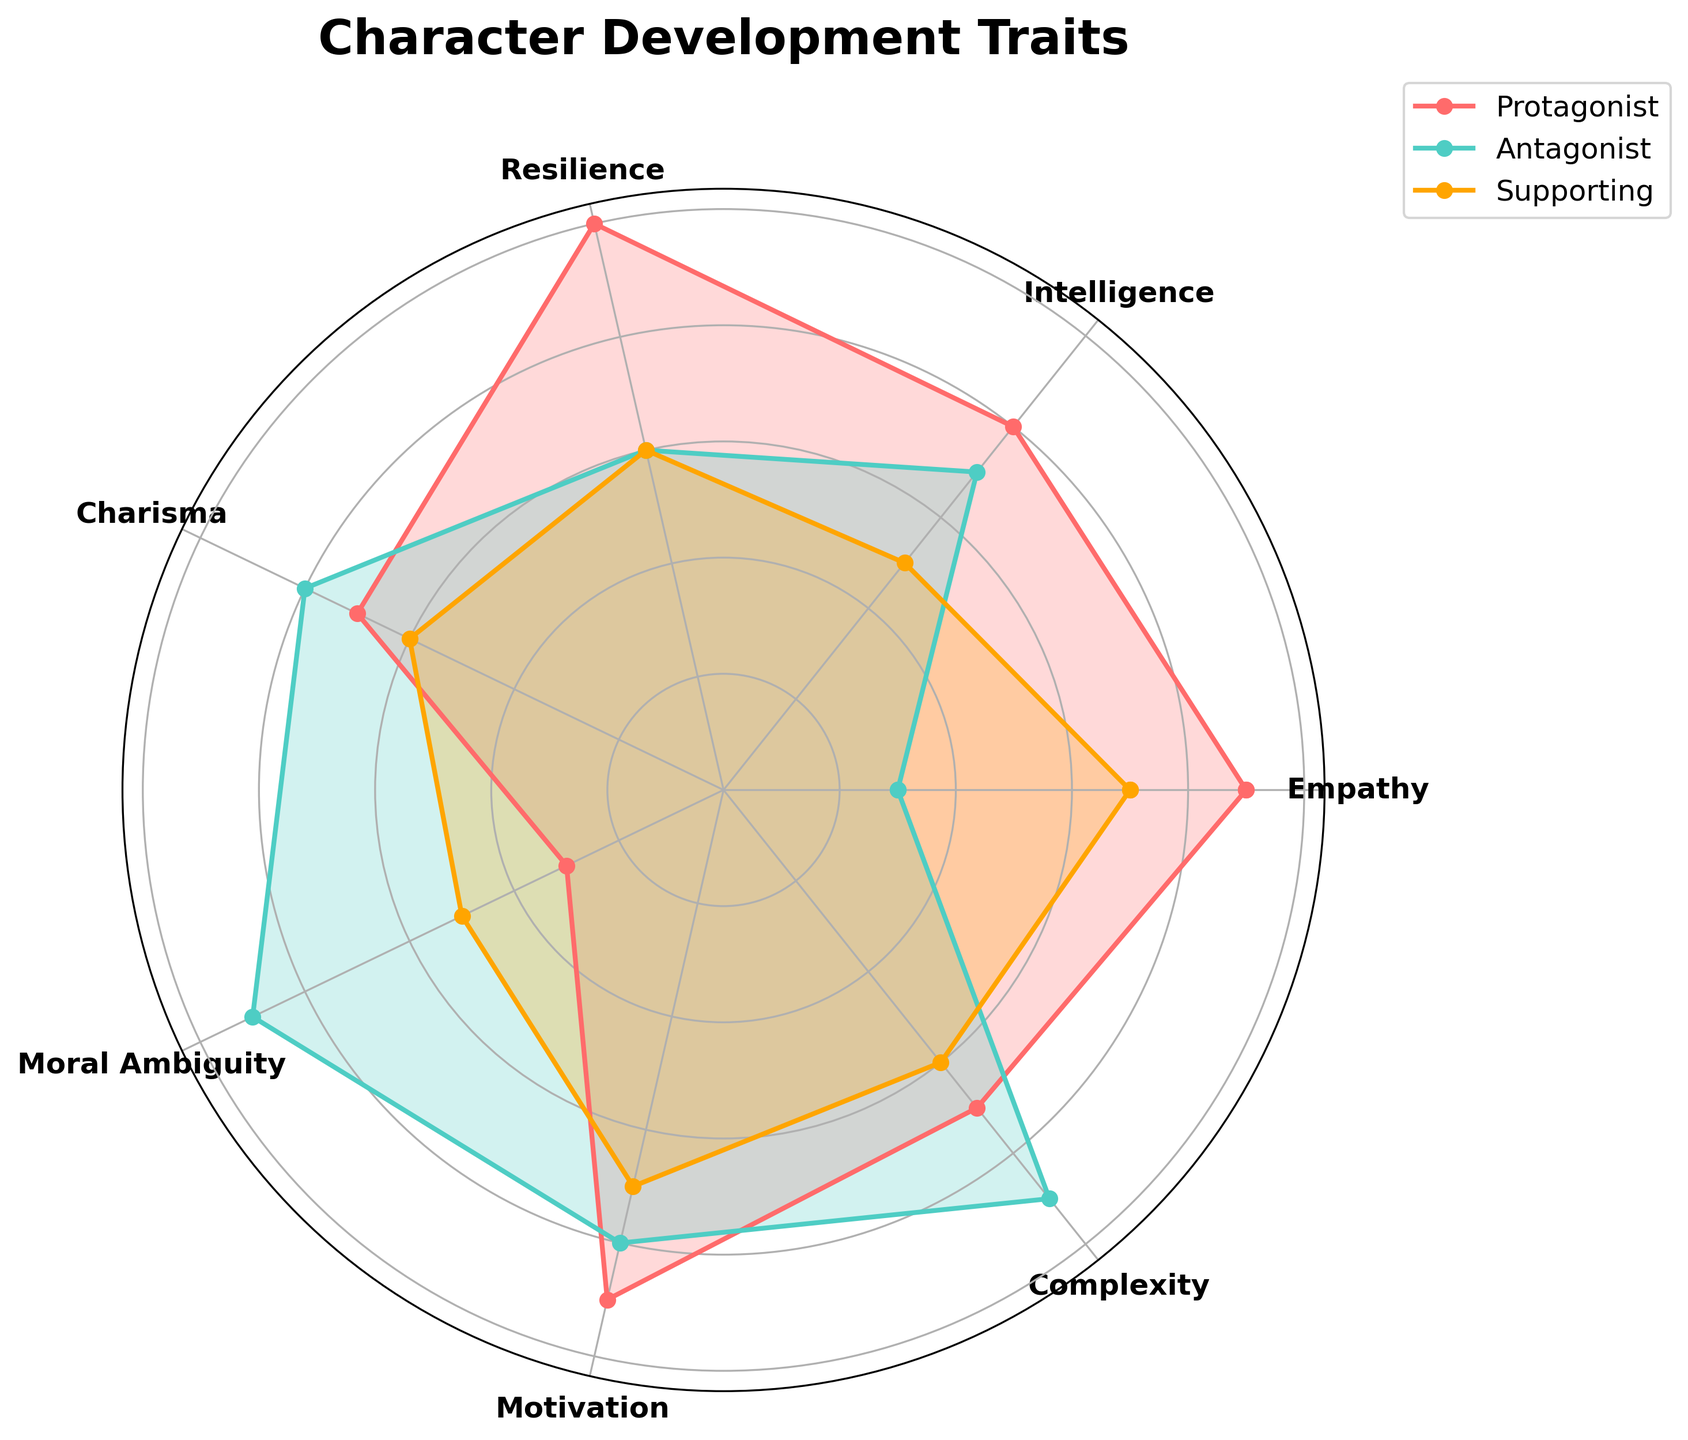what is the highest value for the Protagonist's traits? Looking at the radar chart, the highest plot point for the Protagonist is seen on "Resilience," which reaches the outermost point compared to other traits.
Answer: 10 Which character trait shows the greatest difference between the Protagonist and Antagonist? Comparing each trait value of the Protagonist and Antagonist on the radar chart, "Empathy" shows the greatest difference, with the Protagonist at 9 and the Antagonist at 3, which is a difference of 6.
Answer: Empathy Are there any traits where the Supporting Character has the same value as the Antagonist? Looking through the radar chart where both Supporting Character and Antagonist values overlap exactly, we see that they both share a value of 6 for the "Complexity" trait.
Answer: Complexity How many traits does the Protagonist have a lower score than the Antagonist? For each trait on the radar chart, compare the scores. The Protagonist has lower values for "Charisma" (7 vs. 8), "Moral Ambiguity" (3 vs. 9), and "Complexity" (7 vs. 9). So, there are 3 traits in total.
Answer: 3 Which trait shows the smallest variance among the Protagonist, Antagonist, and Supporting Characters? By evaluating the range of values for each trait, "Resilience" shows the smallest variance as both the Antagonist and Supporting Characters have the same value of 6, while the Protagonist has 10. Variance: (10 - 6)/2 = 2.
Answer: Resilience What is the average Intelligence score across all three character types? Add up the Intelligence scores for Protagonist (8), Antagonist (7), and Supporting Characters (5) and divide by 3. (8 + 7 + 5) / 3 = 6.
Answer: 6 In how many traits does the Supporting Character have the highest score compared to Protagonist and Antagonist? Scan the radar chart for each trait. The Supporting Character does not have the highest score in any of the traits.
Answer: 0 Is there a trait where all three character types have the same score? Check each trait on the radar chart for equal values across Protagonist, Antagonist, and Supporting Characters. None of the traits show the same score.
Answer: No Which character has the highest average score across all traits? Calculate the average score across all traits for each character:
Protagonist: (9 + 8 + 10 + 7 + 3 + 9 + 7) / 7 = 7.57
Antagonist: (3 + 7 + 6 + 8 + 9 + 8 + 9) / 7 = 7.14
Supporting: (7 + 5 + 6 + 6 + 5 + 7 + 6) / 7 = 6
The Protagonist has the highest average score.
Answer: Protagonist 